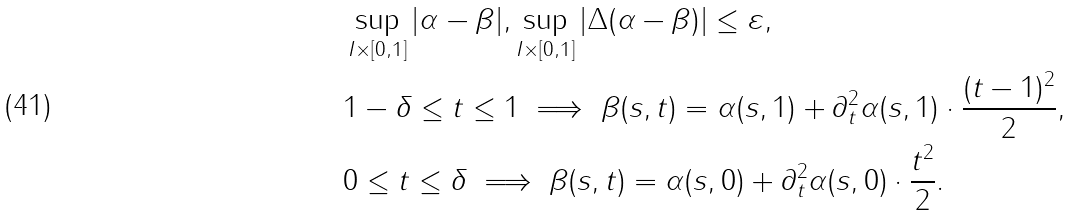<formula> <loc_0><loc_0><loc_500><loc_500>& \sup _ { I \times [ 0 , 1 ] } | \alpha - \beta | , \sup _ { I \times [ 0 , 1 ] } \left | \Delta ( \alpha - \beta ) \right | \leq \varepsilon , \\ & 1 - \delta \leq t \leq 1 \implies \beta ( s , t ) = \alpha ( s , 1 ) + \partial _ { t } ^ { 2 } \alpha ( s , 1 ) \cdot \frac { ( t - 1 ) ^ { 2 } } { 2 } , \\ & 0 \leq t \leq \delta \implies \beta ( s , t ) = \alpha ( s , 0 ) + \partial _ { t } ^ { 2 } \alpha ( s , 0 ) \cdot \frac { t ^ { 2 } } { 2 } .</formula> 